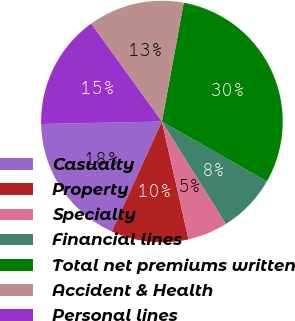<chart> <loc_0><loc_0><loc_500><loc_500><pie_chart><fcel>Casualty<fcel>Property<fcel>Specialty<fcel>Financial lines<fcel>Total net premiums written<fcel>Accident & Health<fcel>Personal lines<nl><fcel>17.86%<fcel>10.35%<fcel>5.35%<fcel>7.85%<fcel>30.37%<fcel>12.86%<fcel>15.36%<nl></chart> 